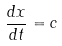Convert formula to latex. <formula><loc_0><loc_0><loc_500><loc_500>\frac { d x } { d t } = c</formula> 